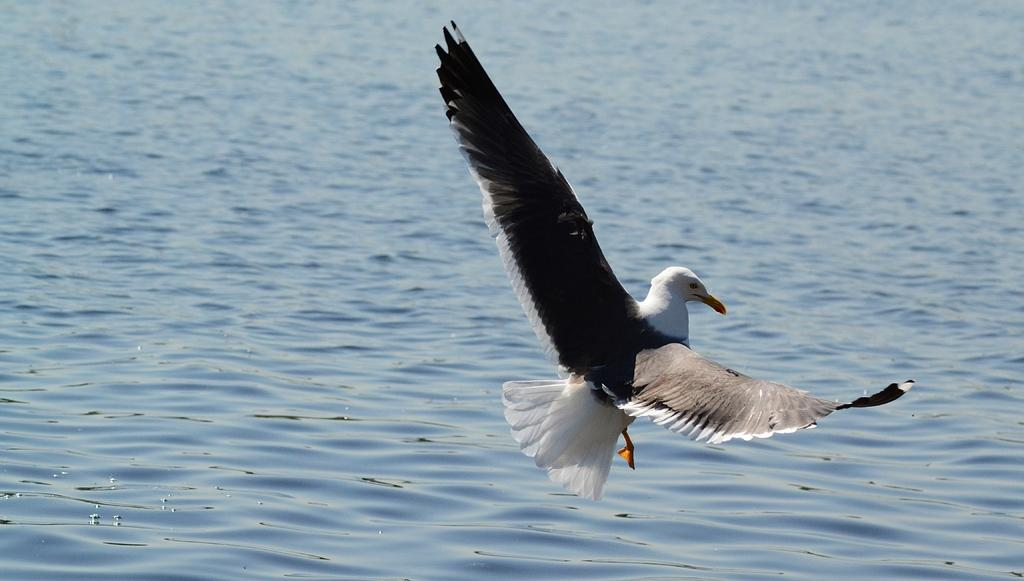What type of animal is in the image? There is a bird in the image. What is the bird doing in the image? The bird is in the air in the image. Where is the bird located in relation to the water surface? The bird is above the water surface in the image. What part of the image does the bird occupy? The bird is in the foreground of the image. What type of lettuce is the bird holding in its beak in the image? There is no lettuce present in the image, and the bird is not holding anything in its beak. How does the bird's haircut look in the image? Birds do not have hair, so the concept of a haircut does not apply to the bird in the image. 